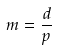Convert formula to latex. <formula><loc_0><loc_0><loc_500><loc_500>m = \frac { d } { p }</formula> 